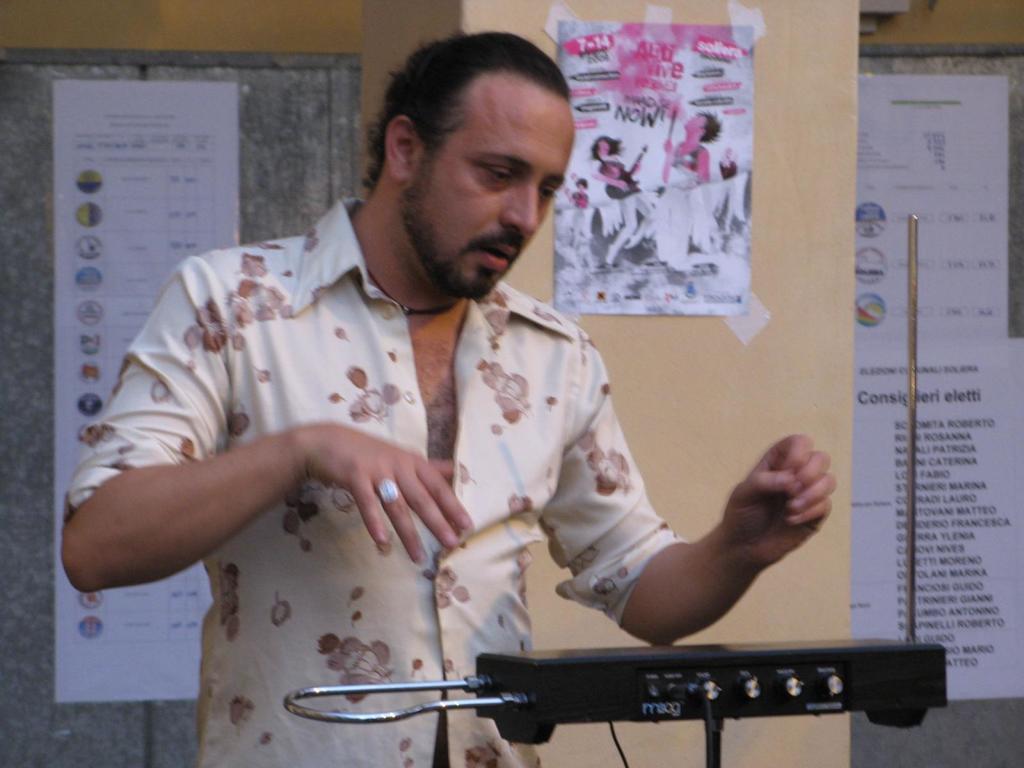Can you describe this image briefly? In this image there is a person standing in front of some object. In the background of the image there are posters attached to the wall. 